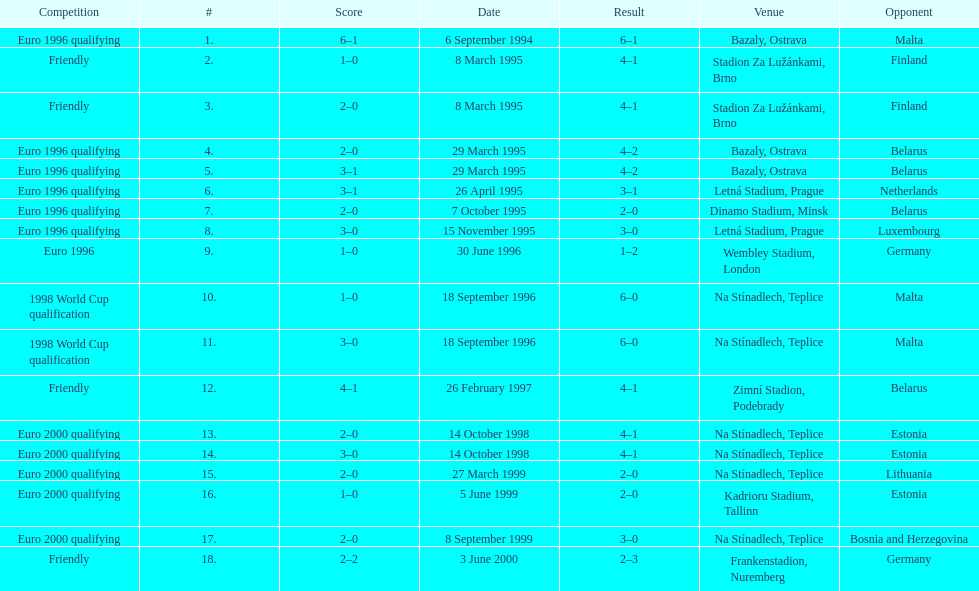List the opponent in which the result was the least out of all the results. Germany. 